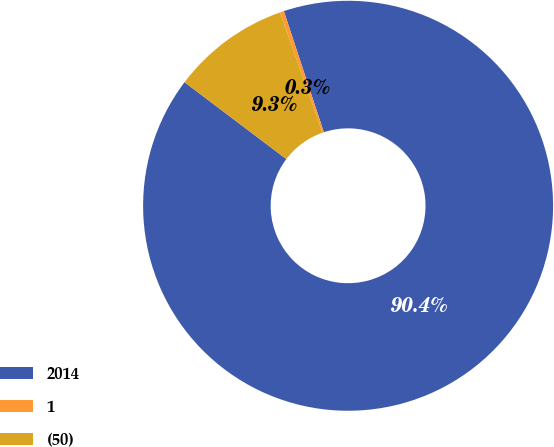Convert chart. <chart><loc_0><loc_0><loc_500><loc_500><pie_chart><fcel>2014<fcel>1<fcel>(50)<nl><fcel>90.37%<fcel>0.31%<fcel>9.32%<nl></chart> 